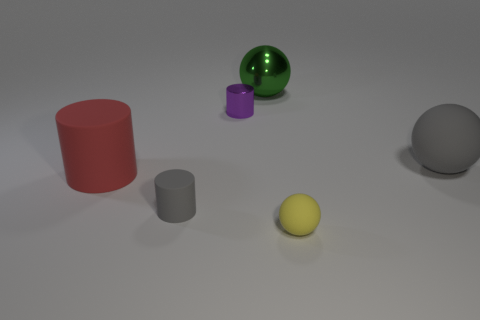What shape is the object that is the same color as the big rubber ball?
Provide a succinct answer. Cylinder. There is a gray rubber thing that is the same shape as the tiny yellow thing; what size is it?
Provide a short and direct response. Large. What is the material of the ball behind the gray sphere?
Your answer should be compact. Metal. Are there fewer tiny gray cylinders that are to the left of the large red matte cylinder than big red things?
Provide a short and direct response. Yes. There is a large gray object behind the big red matte cylinder that is behind the yellow ball; what is its shape?
Ensure brevity in your answer.  Sphere. The metallic cylinder has what color?
Provide a short and direct response. Purple. How many other objects are the same size as the green metal sphere?
Offer a terse response. 2. There is a sphere that is both behind the small gray thing and on the left side of the large gray rubber object; what is its material?
Offer a terse response. Metal. Is the size of the gray thing that is to the left of the yellow rubber object the same as the purple cylinder?
Provide a short and direct response. Yes. Do the metallic sphere and the big cylinder have the same color?
Make the answer very short. No. 